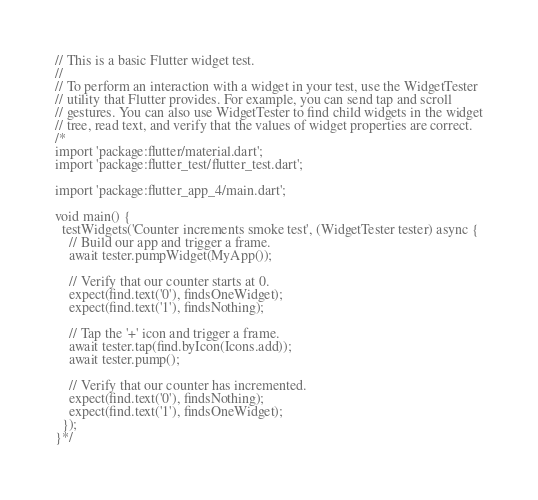Convert code to text. <code><loc_0><loc_0><loc_500><loc_500><_Dart_>// This is a basic Flutter widget test.
//
// To perform an interaction with a widget in your test, use the WidgetTester
// utility that Flutter provides. For example, you can send tap and scroll
// gestures. You can also use WidgetTester to find child widgets in the widget
// tree, read text, and verify that the values of widget properties are correct.
/*
import 'package:flutter/material.dart';
import 'package:flutter_test/flutter_test.dart';

import 'package:flutter_app_4/main.dart';

void main() {
  testWidgets('Counter increments smoke test', (WidgetTester tester) async {
    // Build our app and trigger a frame.
    await tester.pumpWidget(MyApp());

    // Verify that our counter starts at 0.
    expect(find.text('0'), findsOneWidget);
    expect(find.text('1'), findsNothing);

    // Tap the '+' icon and trigger a frame.
    await tester.tap(find.byIcon(Icons.add));
    await tester.pump();

    // Verify that our counter has incremented.
    expect(find.text('0'), findsNothing);
    expect(find.text('1'), findsOneWidget);
  });
}*/
</code> 